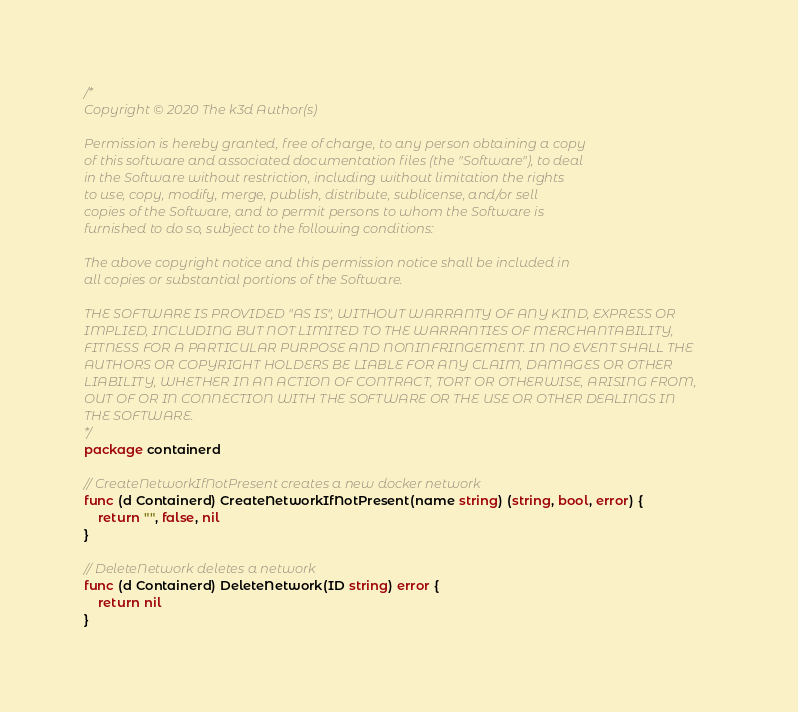Convert code to text. <code><loc_0><loc_0><loc_500><loc_500><_Go_>/*
Copyright © 2020 The k3d Author(s)

Permission is hereby granted, free of charge, to any person obtaining a copy
of this software and associated documentation files (the "Software"), to deal
in the Software without restriction, including without limitation the rights
to use, copy, modify, merge, publish, distribute, sublicense, and/or sell
copies of the Software, and to permit persons to whom the Software is
furnished to do so, subject to the following conditions:

The above copyright notice and this permission notice shall be included in
all copies or substantial portions of the Software.

THE SOFTWARE IS PROVIDED "AS IS", WITHOUT WARRANTY OF ANY KIND, EXPRESS OR
IMPLIED, INCLUDING BUT NOT LIMITED TO THE WARRANTIES OF MERCHANTABILITY,
FITNESS FOR A PARTICULAR PURPOSE AND NONINFRINGEMENT. IN NO EVENT SHALL THE
AUTHORS OR COPYRIGHT HOLDERS BE LIABLE FOR ANY CLAIM, DAMAGES OR OTHER
LIABILITY, WHETHER IN AN ACTION OF CONTRACT, TORT OR OTHERWISE, ARISING FROM,
OUT OF OR IN CONNECTION WITH THE SOFTWARE OR THE USE OR OTHER DEALINGS IN
THE SOFTWARE.
*/
package containerd

// CreateNetworkIfNotPresent creates a new docker network
func (d Containerd) CreateNetworkIfNotPresent(name string) (string, bool, error) {
	return "", false, nil
}

// DeleteNetwork deletes a network
func (d Containerd) DeleteNetwork(ID string) error {
	return nil
}
</code> 